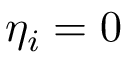Convert formula to latex. <formula><loc_0><loc_0><loc_500><loc_500>\eta _ { i } = 0</formula> 